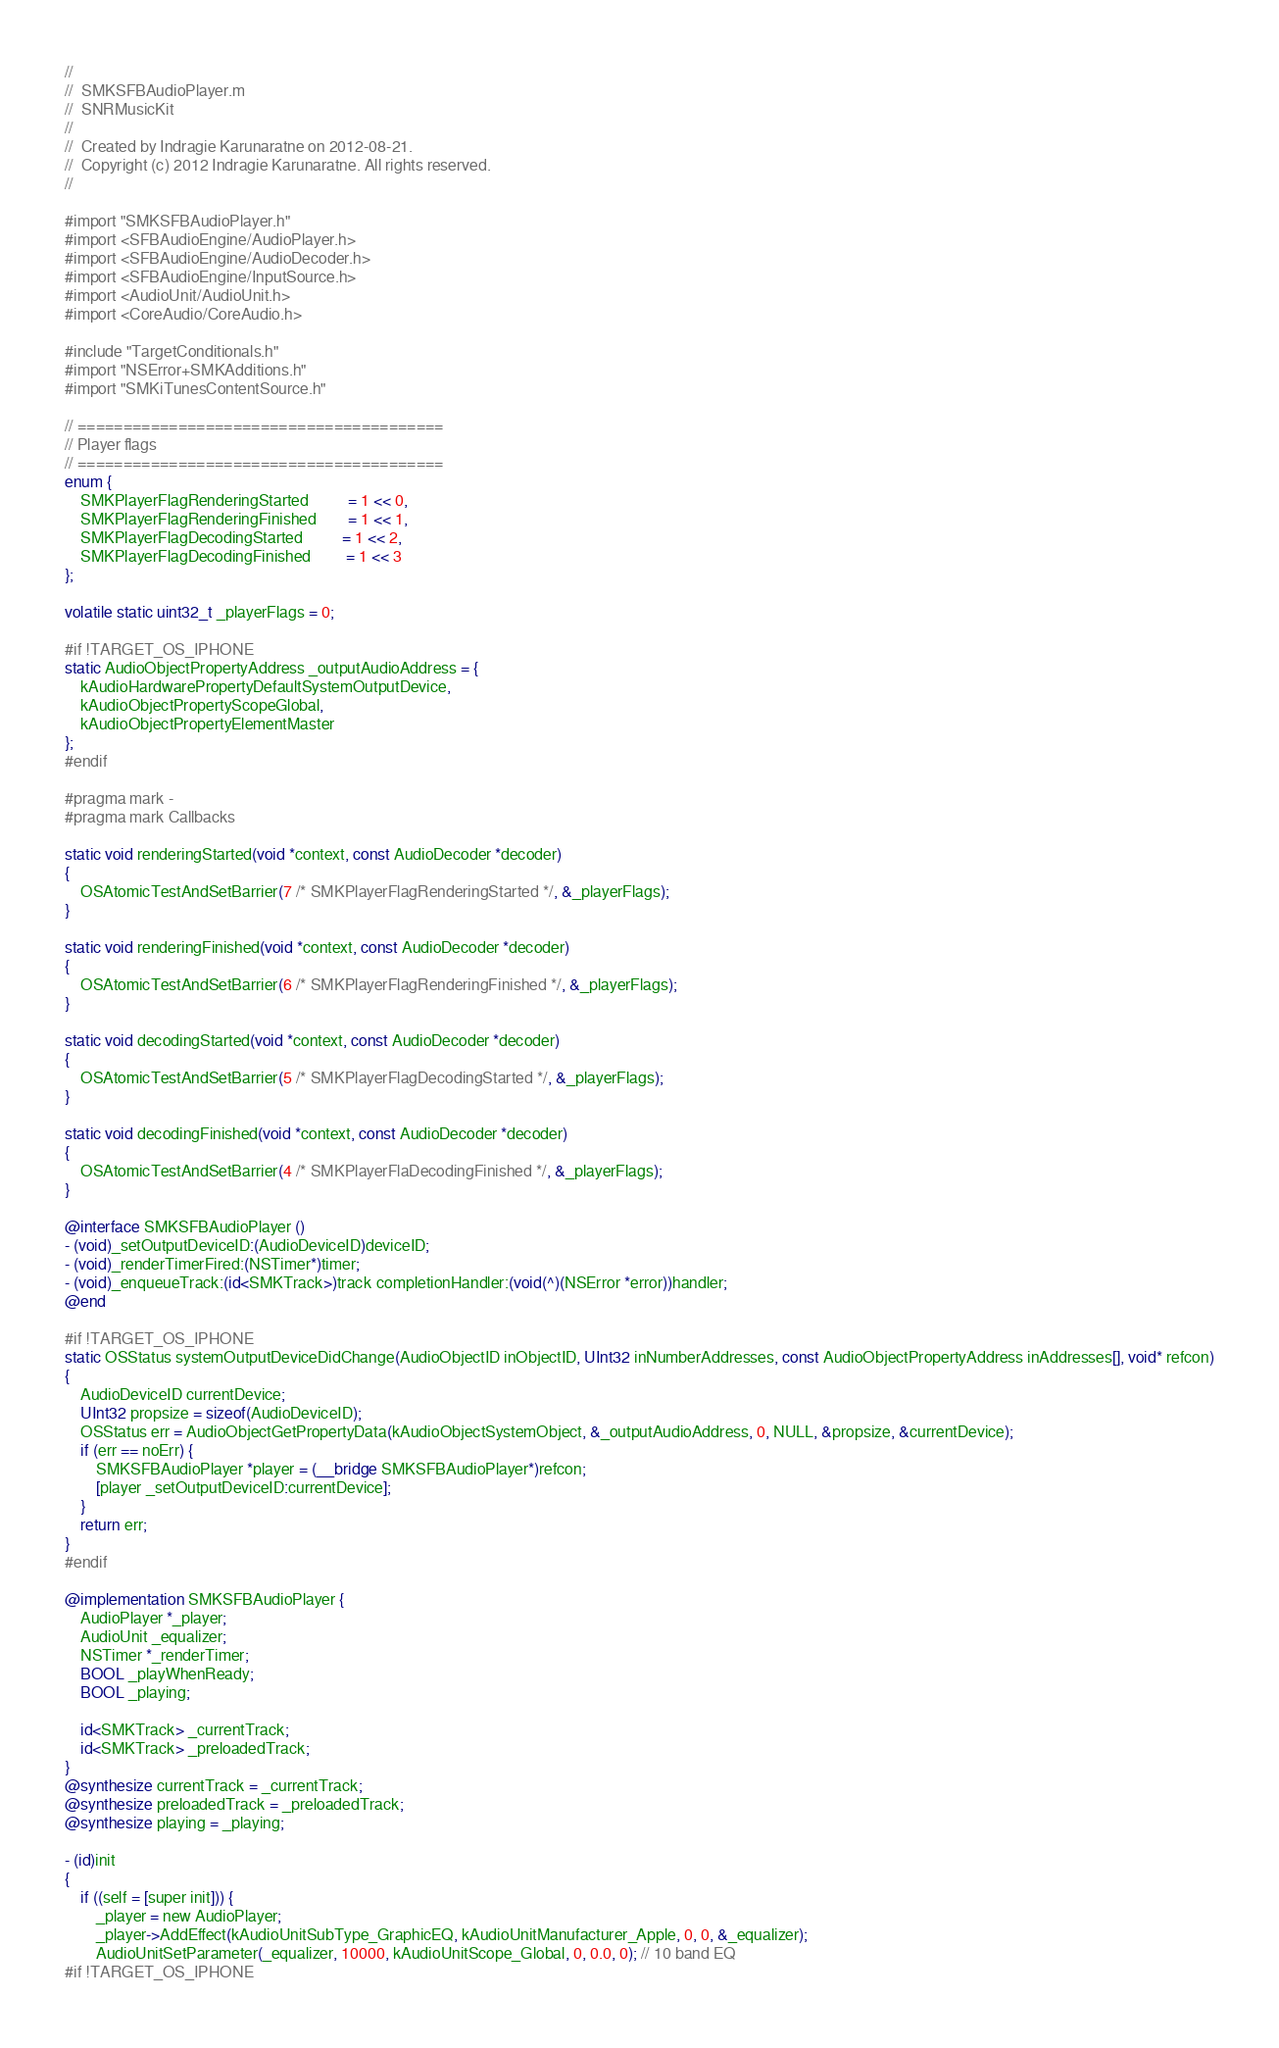Convert code to text. <code><loc_0><loc_0><loc_500><loc_500><_ObjectiveC_>//
//  SMKSFBAudioPlayer.m
//  SNRMusicKit
//
//  Created by Indragie Karunaratne on 2012-08-21.
//  Copyright (c) 2012 Indragie Karunaratne. All rights reserved.
//

#import "SMKSFBAudioPlayer.h"
#import <SFBAudioEngine/AudioPlayer.h>
#import <SFBAudioEngine/AudioDecoder.h>
#import <SFBAudioEngine/InputSource.h>
#import <AudioUnit/AudioUnit.h>
#import <CoreAudio/CoreAudio.h>

#include "TargetConditionals.h"
#import "NSError+SMKAdditions.h"
#import "SMKiTunesContentSource.h"

// ========================================
// Player flags
// ========================================
enum {
	SMKPlayerFlagRenderingStarted		  = 1 << 0,
    SMKPlayerFlagRenderingFinished        = 1 << 1,
    SMKPlayerFlagDecodingStarted          = 1 << 2,
    SMKPlayerFlagDecodingFinished         = 1 << 3
};

volatile static uint32_t _playerFlags = 0;

#if !TARGET_OS_IPHONE
static AudioObjectPropertyAddress _outputAudioAddress = {
    kAudioHardwarePropertyDefaultSystemOutputDevice,
    kAudioObjectPropertyScopeGlobal,
    kAudioObjectPropertyElementMaster
};
#endif

#pragma mark -
#pragma mark Callbacks

static void renderingStarted(void *context, const AudioDecoder *decoder)
{
    OSAtomicTestAndSetBarrier(7 /* SMKPlayerFlagRenderingStarted */, &_playerFlags);
}

static void renderingFinished(void *context, const AudioDecoder *decoder)
{
    OSAtomicTestAndSetBarrier(6 /* SMKPlayerFlagRenderingFinished */, &_playerFlags);
}

static void decodingStarted(void *context, const AudioDecoder *decoder)
{
    OSAtomicTestAndSetBarrier(5 /* SMKPlayerFlagDecodingStarted */, &_playerFlags);
}

static void decodingFinished(void *context, const AudioDecoder *decoder)
{
    OSAtomicTestAndSetBarrier(4 /* SMKPlayerFlaDecodingFinished */, &_playerFlags);
}

@interface SMKSFBAudioPlayer ()
- (void)_setOutputDeviceID:(AudioDeviceID)deviceID;
- (void)_renderTimerFired:(NSTimer*)timer;
- (void)_enqueueTrack:(id<SMKTrack>)track completionHandler:(void(^)(NSError *error))handler;
@end

#if !TARGET_OS_IPHONE
static OSStatus systemOutputDeviceDidChange(AudioObjectID inObjectID, UInt32 inNumberAddresses, const AudioObjectPropertyAddress inAddresses[], void* refcon)
{
    AudioDeviceID currentDevice;
    UInt32 propsize = sizeof(AudioDeviceID);
    OSStatus err = AudioObjectGetPropertyData(kAudioObjectSystemObject, &_outputAudioAddress, 0, NULL, &propsize, &currentDevice);
    if (err == noErr) {
        SMKSFBAudioPlayer *player = (__bridge SMKSFBAudioPlayer*)refcon;
        [player _setOutputDeviceID:currentDevice];
    }
    return err;
}
#endif

@implementation SMKSFBAudioPlayer {
    AudioPlayer *_player;
    AudioUnit _equalizer;
    NSTimer *_renderTimer;
    BOOL _playWhenReady;
    BOOL _playing;
    
    id<SMKTrack> _currentTrack;
    id<SMKTrack> _preloadedTrack;
}
@synthesize currentTrack = _currentTrack;
@synthesize preloadedTrack = _preloadedTrack;
@synthesize playing = _playing;

- (id)init
{
    if ((self = [super init])) {
        _player = new AudioPlayer;
        _player->AddEffect(kAudioUnitSubType_GraphicEQ, kAudioUnitManufacturer_Apple, 0, 0, &_equalizer);
        AudioUnitSetParameter(_equalizer, 10000, kAudioUnitScope_Global, 0, 0.0, 0); // 10 band EQ
#if !TARGET_OS_IPHONE</code> 